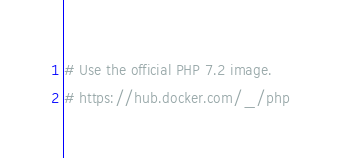<code> <loc_0><loc_0><loc_500><loc_500><_Dockerfile_># Use the official PHP 7.2 image.
# https://hub.docker.com/_/php</code> 